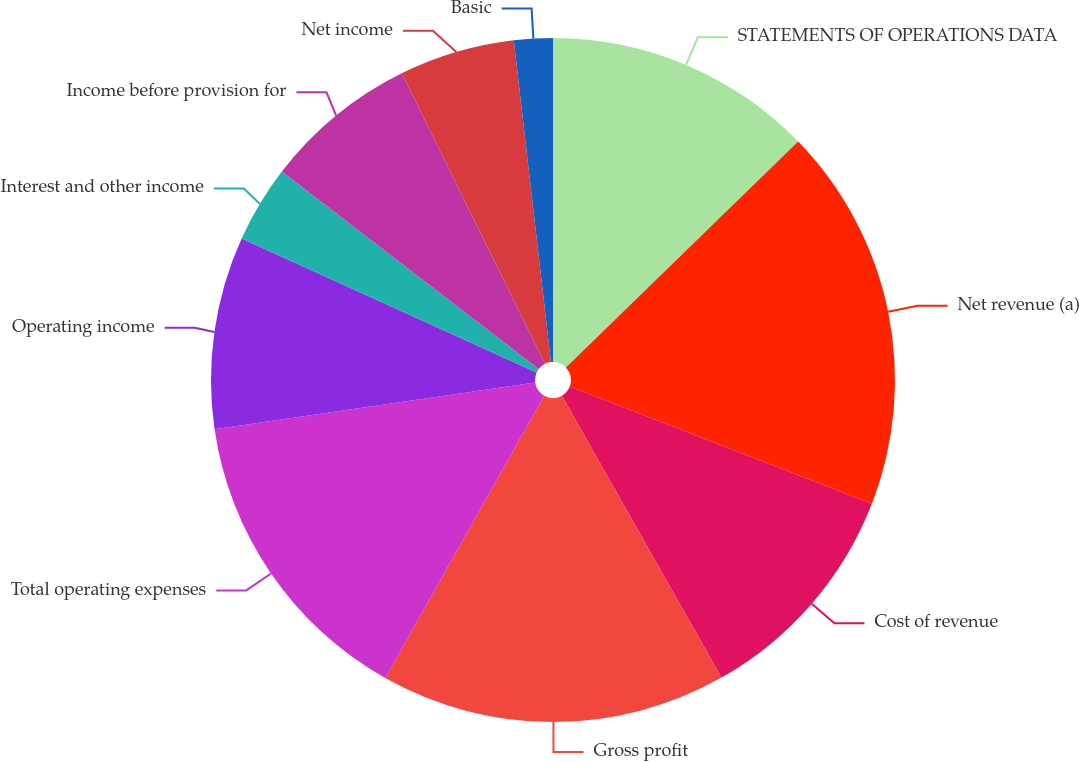Convert chart to OTSL. <chart><loc_0><loc_0><loc_500><loc_500><pie_chart><fcel>STATEMENTS OF OPERATIONS DATA<fcel>Net revenue (a)<fcel>Cost of revenue<fcel>Gross profit<fcel>Total operating expenses<fcel>Operating income<fcel>Interest and other income<fcel>Income before provision for<fcel>Net income<fcel>Basic<nl><fcel>12.72%<fcel>18.17%<fcel>10.91%<fcel>16.36%<fcel>14.54%<fcel>9.09%<fcel>3.64%<fcel>7.28%<fcel>5.46%<fcel>1.83%<nl></chart> 